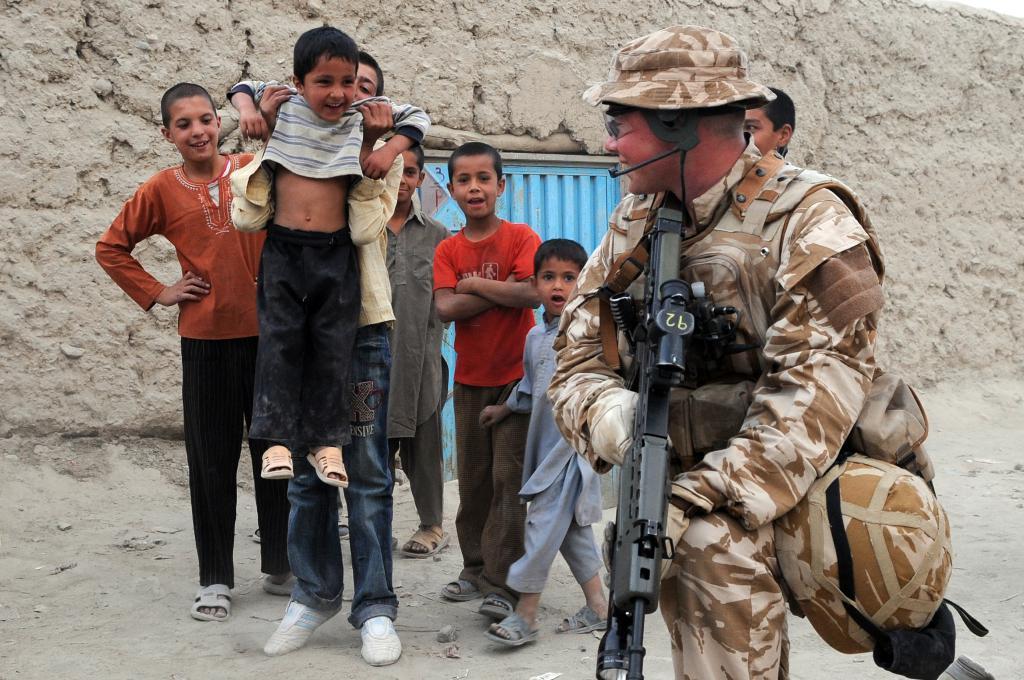How would you summarize this image in a sentence or two? In this image we can see a person wearing uniform and holding the gun and smiling. Behind this person we can see some boys standing on the ground and one of the boy is lifting the kid. In the background we can see the wall with a blue color door. 